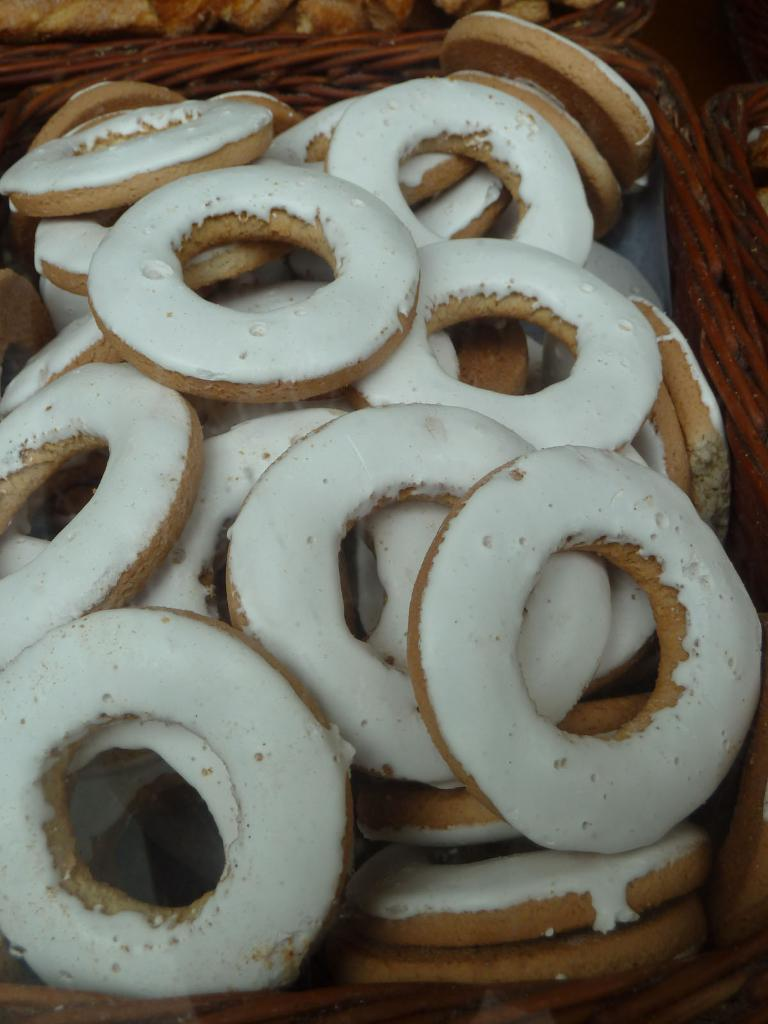What type of food is present in the image? There are donuts in the image. What colors are the donuts? The donuts are in white and cream color. How are the donuts arranged in the image? The donuts are in a basket. What is the color of the basket? The basket is brown in color. What type of pencil can be seen in the image? There is no pencil present in the image. Can you describe the facial expressions of the donuts in the image? Donuts do not have facial expressions, as they are inanimate objects. 